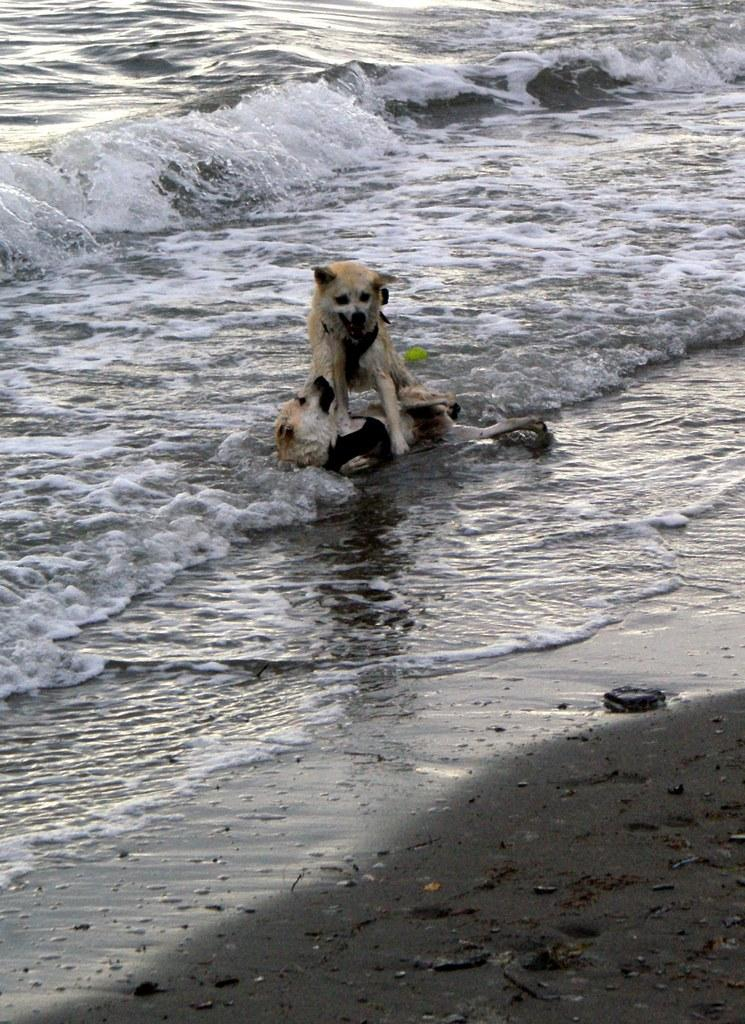What is happening in the water in the image? There are two animals in the water in the image. What other object can be seen in the image? There is a ball in the image. What type of water is depicted in the image? The image depicts a body of water, likely an ocean. When do you think the image was taken? The image appears to have been taken during the day. What type of terrain is visible in the image? The image appears to have been taken near a sandy beach. What type of wood is the pet rolling on in the image? There is no pet or wood present in the image; it features two animals in the water and a ball on a sandy beach. 